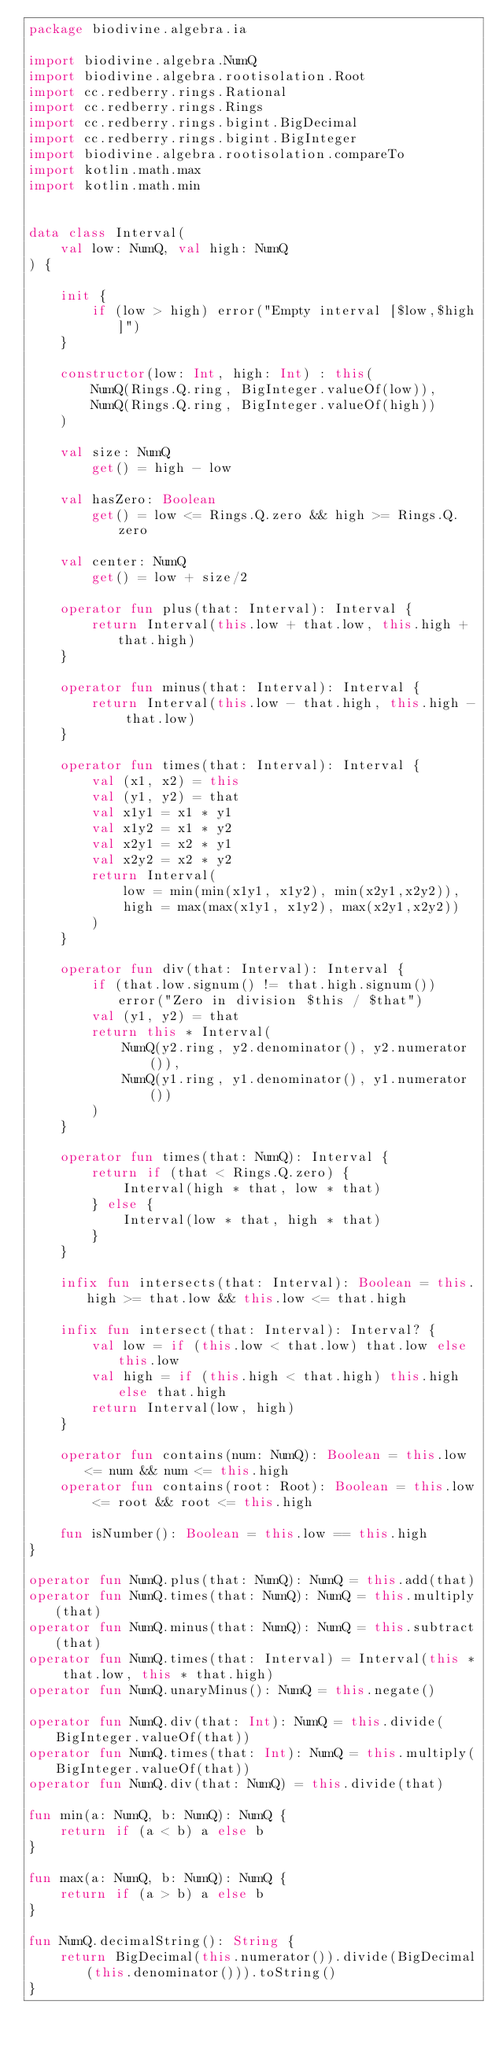Convert code to text. <code><loc_0><loc_0><loc_500><loc_500><_Kotlin_>package biodivine.algebra.ia

import biodivine.algebra.NumQ
import biodivine.algebra.rootisolation.Root
import cc.redberry.rings.Rational
import cc.redberry.rings.Rings
import cc.redberry.rings.bigint.BigDecimal
import cc.redberry.rings.bigint.BigInteger
import biodivine.algebra.rootisolation.compareTo
import kotlin.math.max
import kotlin.math.min


data class Interval(
    val low: NumQ, val high: NumQ
) {

    init {
        if (low > high) error("Empty interval [$low,$high]")
    }

    constructor(low: Int, high: Int) : this(
        NumQ(Rings.Q.ring, BigInteger.valueOf(low)),
        NumQ(Rings.Q.ring, BigInteger.valueOf(high))
    )

    val size: NumQ
        get() = high - low

    val hasZero: Boolean
        get() = low <= Rings.Q.zero && high >= Rings.Q.zero

    val center: NumQ
        get() = low + size/2

    operator fun plus(that: Interval): Interval {
        return Interval(this.low + that.low, this.high + that.high)
    }

    operator fun minus(that: Interval): Interval {
        return Interval(this.low - that.high, this.high - that.low)
    }

    operator fun times(that: Interval): Interval {
        val (x1, x2) = this
        val (y1, y2) = that
        val x1y1 = x1 * y1
        val x1y2 = x1 * y2
        val x2y1 = x2 * y1
        val x2y2 = x2 * y2
        return Interval(
            low = min(min(x1y1, x1y2), min(x2y1,x2y2)),
            high = max(max(x1y1, x1y2), max(x2y1,x2y2))
        )
    }

    operator fun div(that: Interval): Interval {
        if (that.low.signum() != that.high.signum()) error("Zero in division $this / $that")
        val (y1, y2) = that
        return this * Interval(
            NumQ(y2.ring, y2.denominator(), y2.numerator()),
            NumQ(y1.ring, y1.denominator(), y1.numerator())
        )
    }

    operator fun times(that: NumQ): Interval {
        return if (that < Rings.Q.zero) {
            Interval(high * that, low * that)
        } else {
            Interval(low * that, high * that)
        }
    }

    infix fun intersects(that: Interval): Boolean = this.high >= that.low && this.low <= that.high

    infix fun intersect(that: Interval): Interval? {
        val low = if (this.low < that.low) that.low else this.low
        val high = if (this.high < that.high) this.high else that.high
        return Interval(low, high)
    }

    operator fun contains(num: NumQ): Boolean = this.low <= num && num <= this.high
    operator fun contains(root: Root): Boolean = this.low <= root && root <= this.high

    fun isNumber(): Boolean = this.low == this.high
}

operator fun NumQ.plus(that: NumQ): NumQ = this.add(that)
operator fun NumQ.times(that: NumQ): NumQ = this.multiply(that)
operator fun NumQ.minus(that: NumQ): NumQ = this.subtract(that)
operator fun NumQ.times(that: Interval) = Interval(this * that.low, this * that.high)
operator fun NumQ.unaryMinus(): NumQ = this.negate()

operator fun NumQ.div(that: Int): NumQ = this.divide(BigInteger.valueOf(that))
operator fun NumQ.times(that: Int): NumQ = this.multiply(BigInteger.valueOf(that))
operator fun NumQ.div(that: NumQ) = this.divide(that)

fun min(a: NumQ, b: NumQ): NumQ {
    return if (a < b) a else b
}

fun max(a: NumQ, b: NumQ): NumQ {
    return if (a > b) a else b
}

fun NumQ.decimalString(): String {
    return BigDecimal(this.numerator()).divide(BigDecimal(this.denominator())).toString()
}</code> 